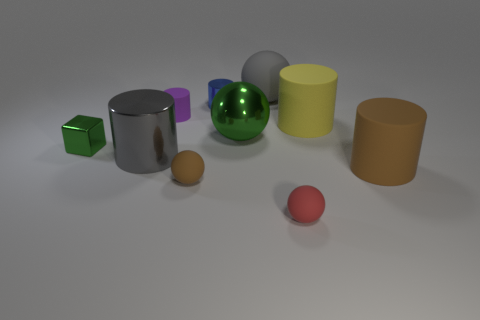Are there any other things that are the same shape as the tiny green metal object?
Make the answer very short. No. The tiny brown matte thing has what shape?
Provide a short and direct response. Sphere. Are there any big things right of the tiny purple thing?
Provide a succinct answer. Yes. Are the yellow thing and the gray thing in front of the yellow thing made of the same material?
Provide a short and direct response. No. There is a blue metal thing on the left side of the gray sphere; does it have the same shape as the small red matte thing?
Provide a succinct answer. No. What number of tiny red balls are made of the same material as the big yellow object?
Offer a very short reply. 1. How many objects are rubber objects that are behind the big brown object or shiny things?
Your answer should be very brief. 7. The blue shiny thing has what size?
Your response must be concise. Small. There is a green thing that is to the right of the small rubber ball on the left side of the red object; what is it made of?
Offer a very short reply. Metal. There is a shiny cylinder on the right side of the gray cylinder; is it the same size as the large gray cylinder?
Make the answer very short. No. 